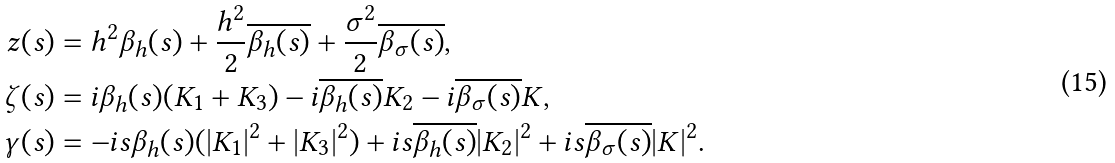Convert formula to latex. <formula><loc_0><loc_0><loc_500><loc_500>z ( s ) & = h ^ { 2 } \beta _ { h } ( s ) + \frac { h ^ { 2 } } { 2 } \overline { \beta _ { h } ( s ) } + \frac { \sigma ^ { 2 } } { 2 } \overline { \beta _ { \sigma } ( s ) } , \\ \zeta ( s ) & = i \beta _ { h } ( s ) ( K _ { 1 } + K _ { 3 } ) - i \overline { \beta _ { h } ( s ) } K _ { 2 } - i \overline { \beta _ { \sigma } ( s ) } K , \\ \gamma ( s ) & = - i s \beta _ { h } ( s ) ( | K _ { 1 } | ^ { 2 } + | K _ { 3 } | ^ { 2 } ) + i s \overline { \beta _ { h } ( s ) } | K _ { 2 } | ^ { 2 } + i s \overline { \beta _ { \sigma } ( s ) } | K | ^ { 2 } .</formula> 